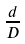Convert formula to latex. <formula><loc_0><loc_0><loc_500><loc_500>\frac { d } { D }</formula> 